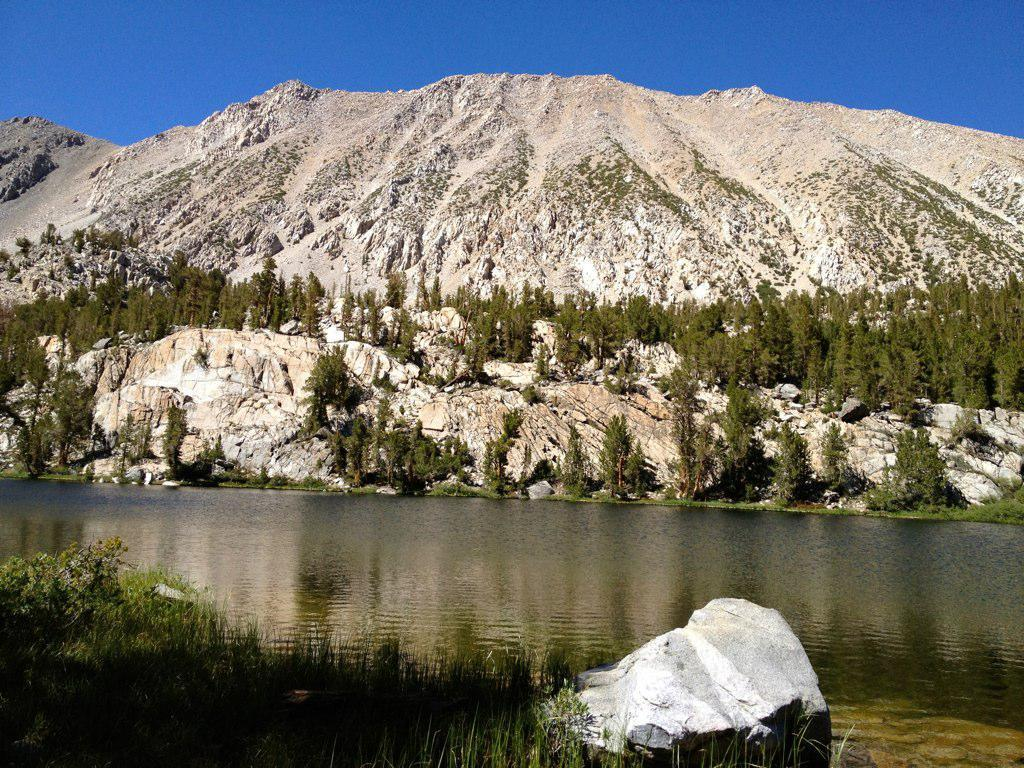What is one of the natural elements present in the image? There is water in the image. What type of terrain can be seen in the image? There are stones, grass, and trees in the image. What type of landscape feature is visible in the image? There are mountains in the image. What part of the natural environment is visible in the image? The sky is visible in the image. Can you describe the monkey sitting on the chair in the image? There is no monkey or chair present in the image. 